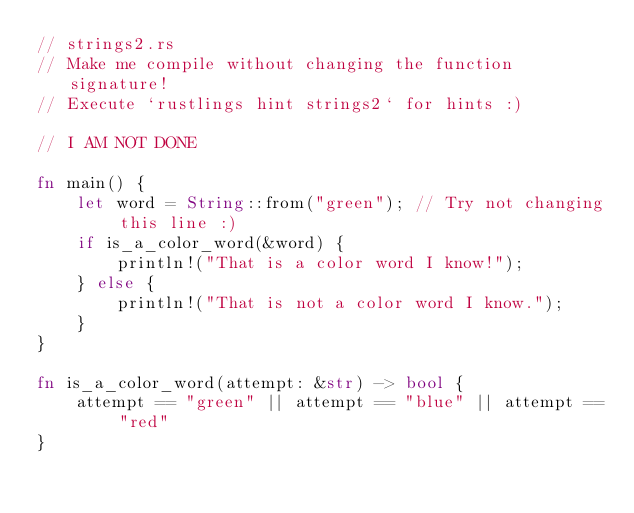<code> <loc_0><loc_0><loc_500><loc_500><_Rust_>// strings2.rs
// Make me compile without changing the function signature!
// Execute `rustlings hint strings2` for hints :)

// I AM NOT DONE

fn main() {
    let word = String::from("green"); // Try not changing this line :)
    if is_a_color_word(&word) {
        println!("That is a color word I know!");
    } else {
        println!("That is not a color word I know.");
    }
}

fn is_a_color_word(attempt: &str) -> bool {
    attempt == "green" || attempt == "blue" || attempt == "red"
}
</code> 